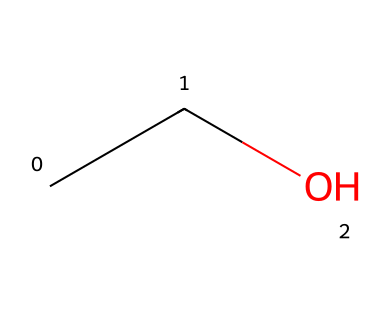How many carbon atoms are present in the chemical structure? The SMILES representation "CCO" shows there are two 'C' characters, indicating two carbon atoms in the structure of ethanol.
Answer: 2 What type of functional group is present in this chemical? In "CCO," the 'O' at the end signifies the presence of a hydroxyl (-OH) group, which characterizes alcohols.
Answer: hydroxyl group Is this chemical polar or nonpolar? The presence of the hydroxyl group in ethanol leads to significant polarity, as it can form hydrogen bonds with water.
Answer: polar How many hydrogen atoms are in the structure of ethanol? Each carbon in "CCO" is bonded to enough hydrogen atoms to satisfy carbon’s four-bond requirement: 5 hydrogen atoms total (3 from one carbon and 2 from the other carbon).
Answer: 6 What makes this chemical flammable? The presence of carbon and hydrogen allows for combustion in the presence of oxygen, releasing energy as flames, typical of hydrocarbons.
Answer: carbon and hydrogen What is the molecular formula of this substance? The molecular structure "CCO" corresponds to the formula C2H6O, where there are 2 carbons, 6 hydrogens, and 1 oxygen.
Answer: C2H6O In what state is this chemical at room temperature? Ethanol is a liquid at room temperature due to its low boiling point (78.37 °C), which is indicated by its functional group and molecular structure.
Answer: liquid 